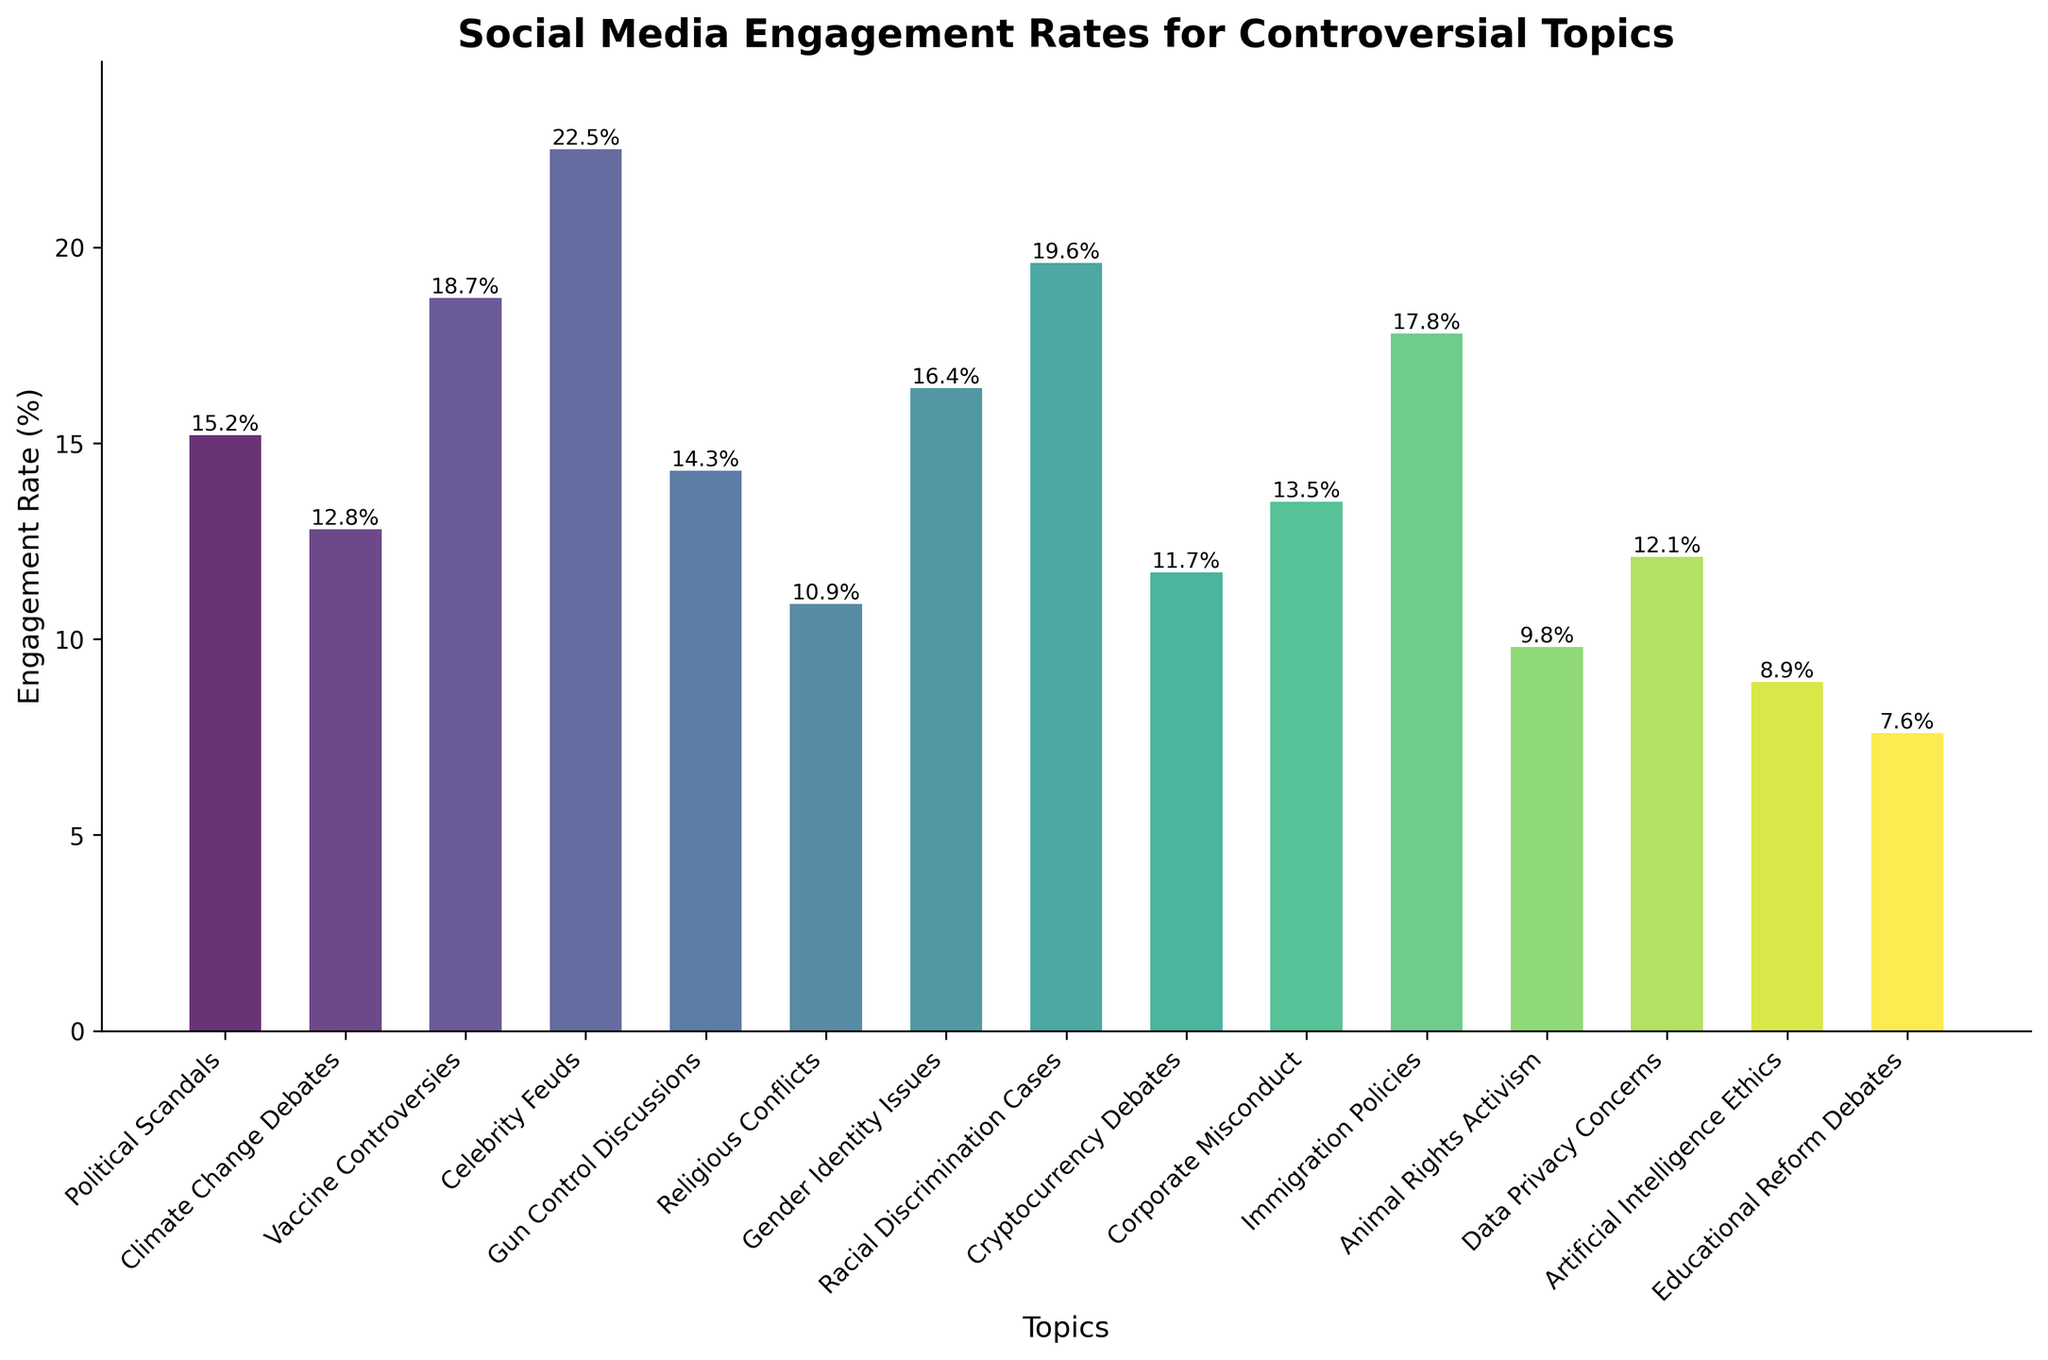What's the most engaging controversial topic on social media? According to the bar chart, the topic with the highest engagement rate is "Celebrity Feuds" with 22.5%. By scanning the bars visually, "Celebrity Feuds" stands taller than the others.
Answer: Celebrity Feuds (22.5%) Which controversial topic has the lowest engagement rate? By looking at the bar heights, the shortest bar represents "Educational Reform Debates" with an engagement rate of 7.6%.
Answer: Educational Reform Debates (7.6%) What's the difference in engagement rate between "Vaccine Controversies" and "Climate Change Debates"? The engagement rate for "Vaccine Controversies" is 18.7% and for "Climate Change Debates" is 12.8%. The difference is 18.7% - 12.8%.
Answer: 5.9% Which topics have an engagement rate between 10% and 15%? Observing the bars, the topics with engagement rates falling between 10% and 15% are "Climate Change Debates" (12.8%), "Gun Control Discussions" (14.3%), "Religious Conflicts" (10.9%), "Cryptocurrency Debates" (11.7%), "Corporate Misconduct" (13.5%), and "Data Privacy Concerns" (12.1%).
Answer: Climate Change Debates, Gun Control Discussions, Religious Conflicts, Cryptocurrency Debates, Corporate Misconduct, Data Privacy Concerns What is the average engagement rate of "Political Scandals," "Immigration Policies," and "Racial Discrimination Cases"? The engagement rates for "Political Scandals" are 15.2%, "Immigration Policies" are 17.8%, and "Racial Discrimination Cases" are 19.6%. The average is (15.2 + 17.8 + 19.6) / 3.
Answer: 17.5% Which topic's engagement rate is closest to the median engagement rate of all topics? First, list and sort the engagement rates: 7.6%, 8.9%, 9.8%, 10.9%, 11.7%, 12.1%, 12.8%, 13.5%, 14.3%, 15.2%, 16.4%, 17.8%, 18.7%, 19.6%, 22.5%. The median is the middle value (13.5%), which corresponds to "Corporate Misconduct".
Answer: Corporate Misconduct What are the engagement rates for "Animal Rights Activism" and "Gender Identity Issues"? Compare their heights. The engagement rate for "Animal Rights Activism" is 9.8%, and for "Gender Identity Issues", it is 16.4%. Comparing the heights visually, "Gender Identity Issues" is significantly taller than "Animal Rights Activism".
Answer: 9.8% and 16.4%, "Gender Identity Issues" is taller How much higher is the engagement rate for "Celebrity Feuds" compared to "Artificial Intelligence Ethics"? The engagement rate for "Celebrity Feuds" is 22.5%, and for "Artificial Intelligence Ethics" is 8.9%. The difference is 22.5% - 8.9%.
Answer: 13.6% Is the engagement rate for "Gun Control Discussions" greater than the rate for "Cryptocurrency Debates"? The engagement rate for "Gun Control Discussions" is 14.3%, and for "Cryptocurrency Debates" is 11.7%. Comparing the two, 14.3% is greater than 11.7%.
Answer: Yes What’s the total engagement rate for topics under 10%? Only three topics have engagement rates under 10%: "Artificial Intelligence Ethics" (8.9%), "Educational Reform Debates" (7.6%), and "Animal Rights Activism" (9.8%). The total is 8.9% + 7.6% + 9.8%.
Answer: 26.3% 